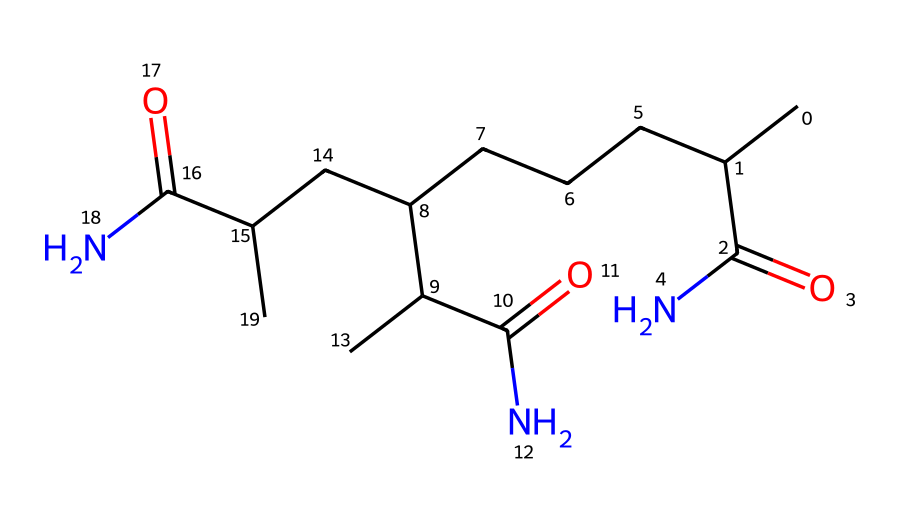what is the main functional group present in this chemical? The chemical contains multiple carbonyl groups (C=O), which are characteristic of amides, as indicated by the presence of nitrogen atoms bonded to the carbon atoms with carbonyl functionality.
Answer: amide how many carbon atoms are in the structure? By analyzing the SMILES representation, we can count a total of 18 carbon atoms present in this molecule, which form the main chain and branches.
Answer: 18 what type of polymer is represented by this chemical? This chemical is a polyacrylamide, which is a type of synthetic polymer notable for its use in soil stabilization and as a Non-Newtonian fluid.
Answer: polyacrylamide how many amide groups are in the structure? The structure contains three amide groups, each indicated by the presence of carbonyl and nitrogen adjacent to one another at various points along the molecule.
Answer: 3 what property makes this chemical a Non-Newtonian fluid? The presence of long-chain polymer structures allows this chemical to exhibit shear-thinning behavior, which is characteristic of Non-Newtonian fluids, leading to changes in viscosity under applied stress.
Answer: shear-thinning in which application is this chemical commonly used in outdoor events? This chemical is used in soil stabilization to prevent erosion and improve water retention in outdoor concert venues, making it easier to manage large crowds and heavy equipment.
Answer: soil stabilization 